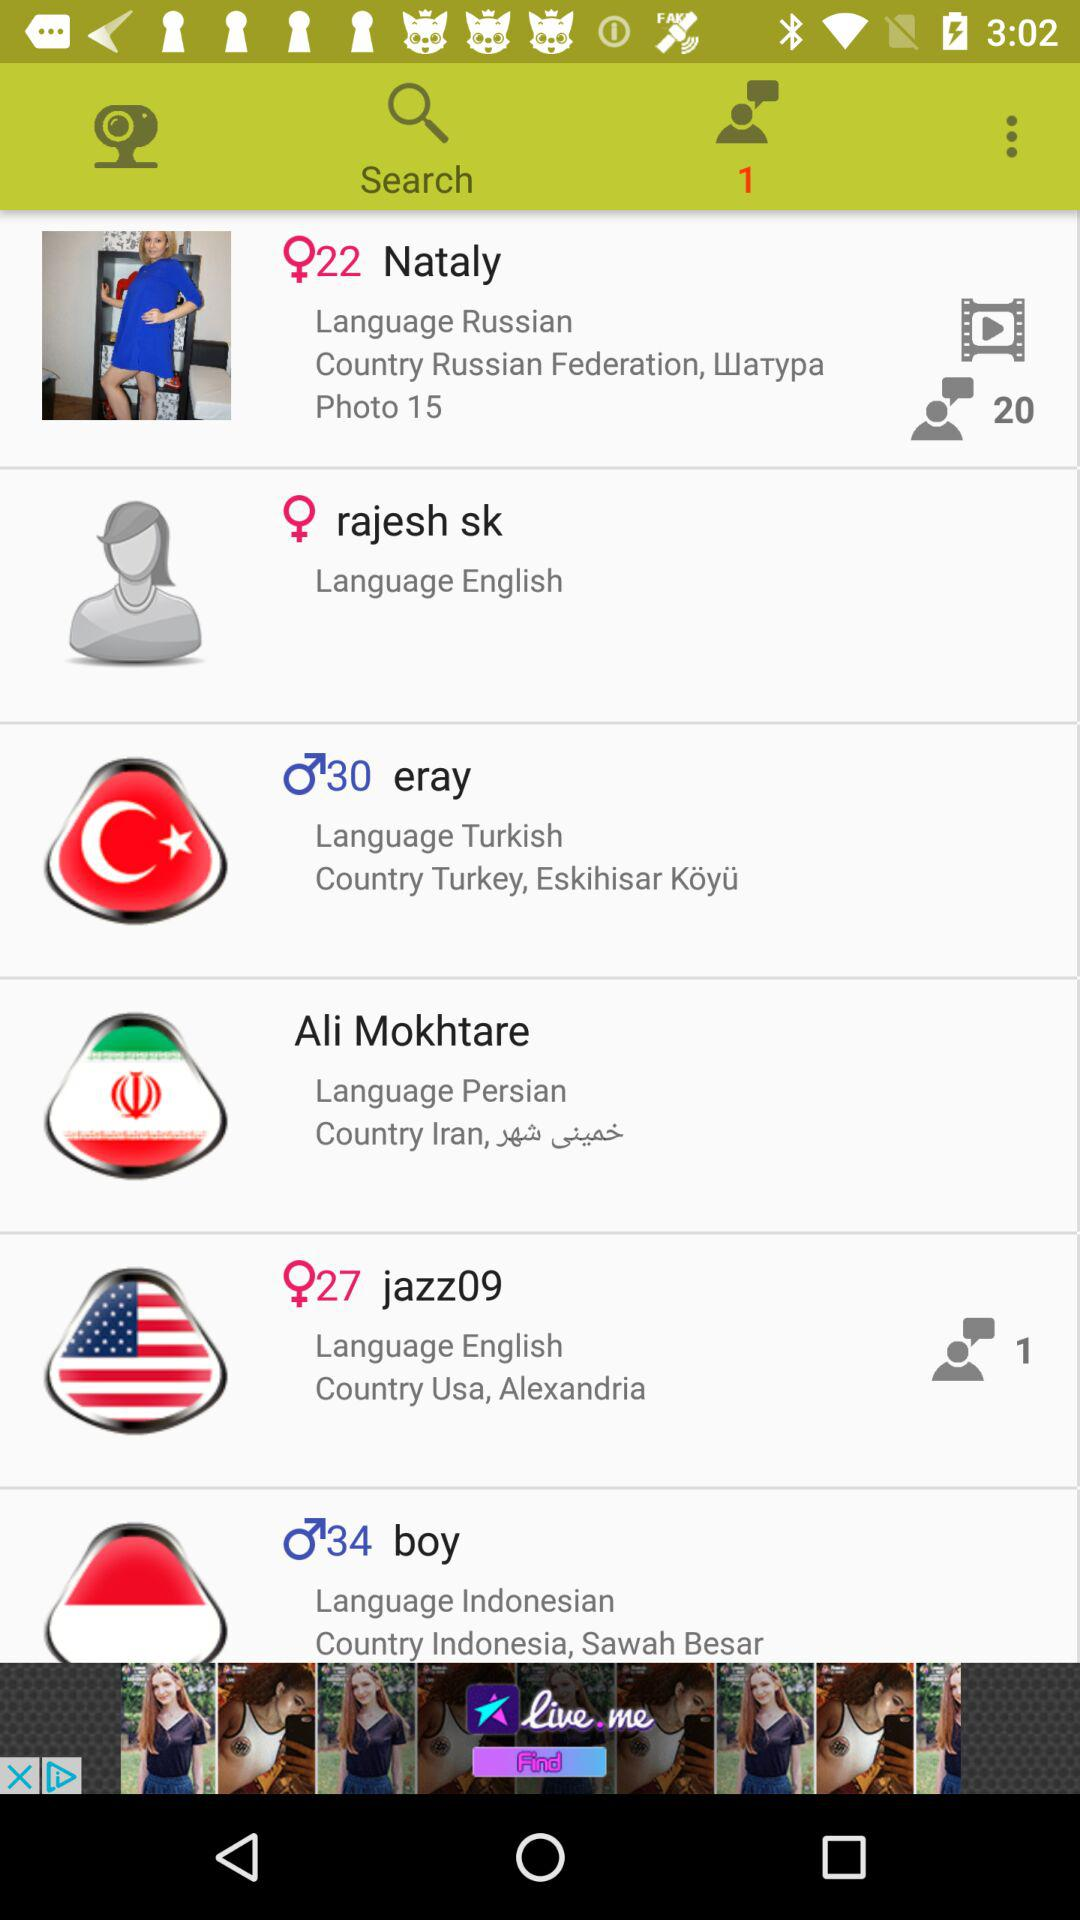How many photos are there of Nataly? There are 15 photos of Nataly. 